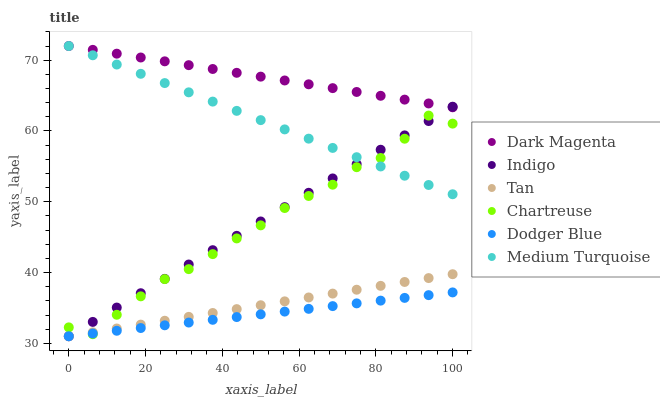Does Dodger Blue have the minimum area under the curve?
Answer yes or no. Yes. Does Dark Magenta have the maximum area under the curve?
Answer yes or no. Yes. Does Chartreuse have the minimum area under the curve?
Answer yes or no. No. Does Chartreuse have the maximum area under the curve?
Answer yes or no. No. Is Dark Magenta the smoothest?
Answer yes or no. Yes. Is Chartreuse the roughest?
Answer yes or no. Yes. Is Chartreuse the smoothest?
Answer yes or no. No. Is Dark Magenta the roughest?
Answer yes or no. No. Does Indigo have the lowest value?
Answer yes or no. Yes. Does Chartreuse have the lowest value?
Answer yes or no. No. Does Medium Turquoise have the highest value?
Answer yes or no. Yes. Does Chartreuse have the highest value?
Answer yes or no. No. Is Tan less than Dark Magenta?
Answer yes or no. Yes. Is Dark Magenta greater than Tan?
Answer yes or no. Yes. Does Medium Turquoise intersect Indigo?
Answer yes or no. Yes. Is Medium Turquoise less than Indigo?
Answer yes or no. No. Is Medium Turquoise greater than Indigo?
Answer yes or no. No. Does Tan intersect Dark Magenta?
Answer yes or no. No. 